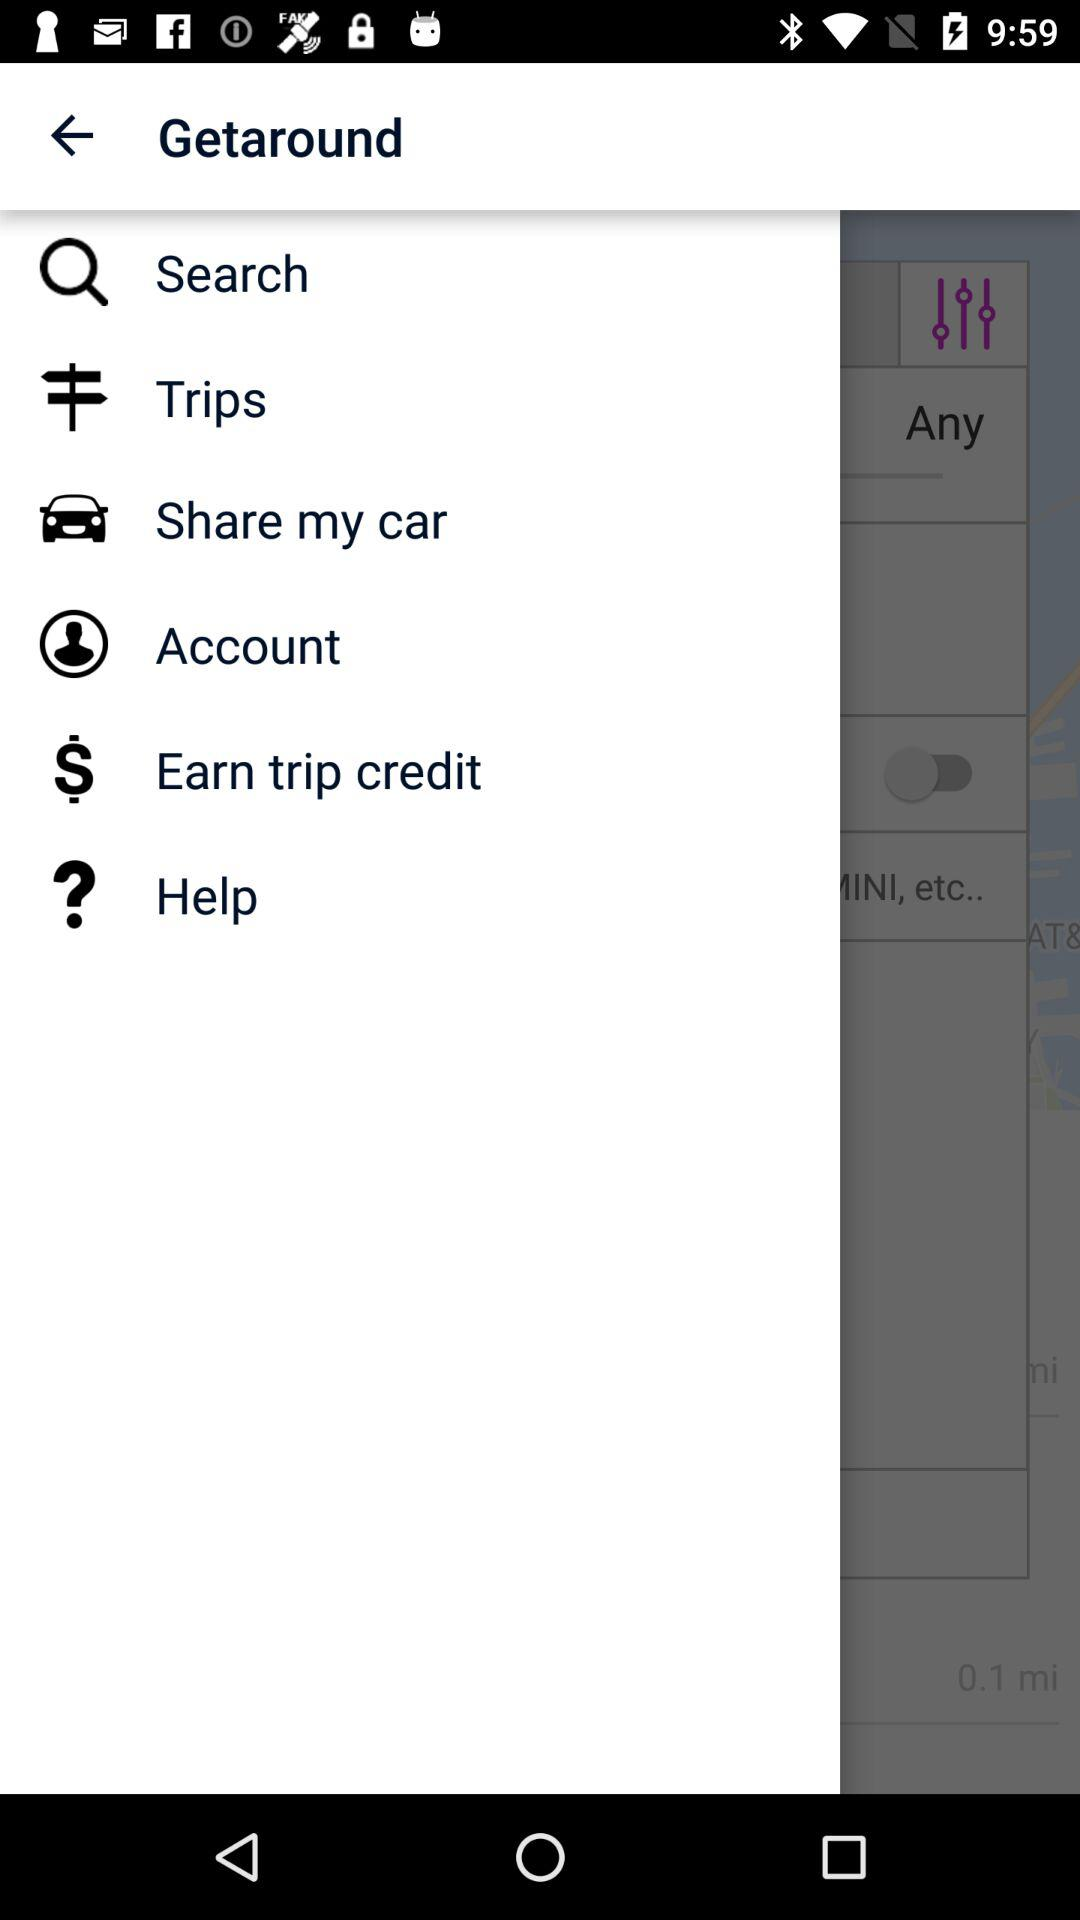What is the application name? The application name is "Getaround". 